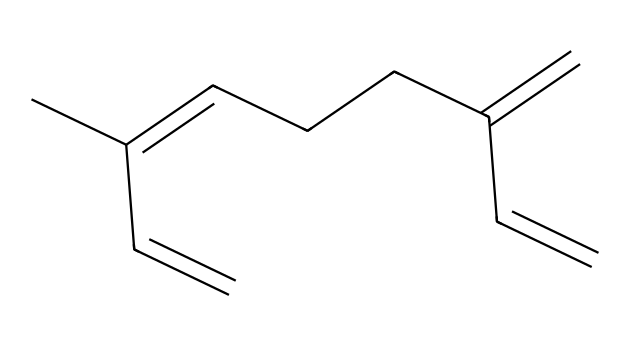What is the total number of carbon atoms in myrcene? By examining the SMILES representation, we can count the number of "C" characters which indicate carbon atoms. In this structure, there are a total of 10 carbon atoms.
Answer: 10 How many double bonds are present in this chemical? Looking at the structure, double bonds are typically represented by the "=" sign in the SMILES notation. In myrcene, there are four instances of "=" indicating four double bonds.
Answer: 4 What type of chemical is myrcene? Myrcene is categorized as a terpene, which can be inferred from its structure consisting of a hydrocarbon chain with multiple double bonds. Terpenes are characterized by their terpene unit structures.
Answer: terpene Does myrcene have any chiral centers? By analyzing the arrangement of carbon atoms, we can determine if any carbon is connected to four different substituents, which defines chirality. In myrcene, none of the carbon atoms meet this criterion, indicating there are no chiral centers.
Answer: no What is the molecular formula of myrcene? The molecular formula can be derived by counting the percentages of carbon (C) and hydrogen (H) present in the structure. For myrcene, the arrangement indicates the formula is C10H16.
Answer: C10H16 Which functional groups are prevalent in myrcene? While myrcene primarily consists of a hydrocarbon structure, the presence of double bonds indicates it contains alkene functional groups. Specifically, there are multiple alkene sites in the structure.
Answer: alkene 